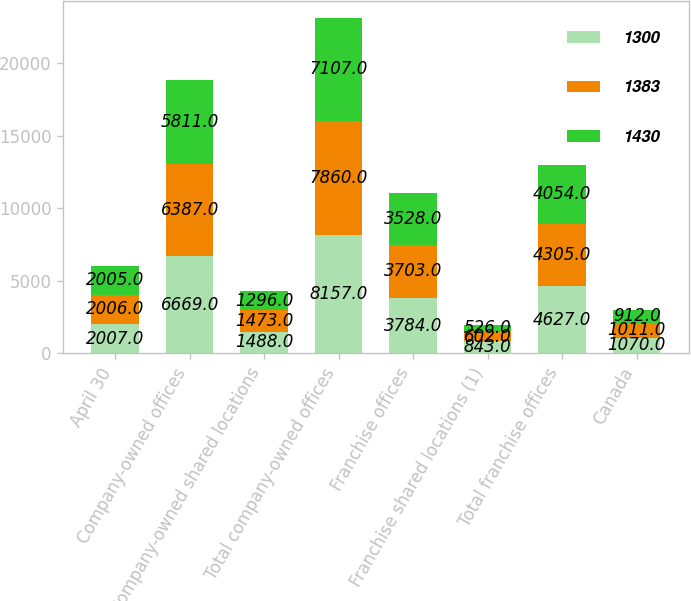Convert chart. <chart><loc_0><loc_0><loc_500><loc_500><stacked_bar_chart><ecel><fcel>April 30<fcel>Company-owned offices<fcel>Company-owned shared locations<fcel>Total company-owned offices<fcel>Franchise offices<fcel>Franchise shared locations (1)<fcel>Total franchise offices<fcel>Canada<nl><fcel>1300<fcel>2007<fcel>6669<fcel>1488<fcel>8157<fcel>3784<fcel>843<fcel>4627<fcel>1070<nl><fcel>1383<fcel>2006<fcel>6387<fcel>1473<fcel>7860<fcel>3703<fcel>602<fcel>4305<fcel>1011<nl><fcel>1430<fcel>2005<fcel>5811<fcel>1296<fcel>7107<fcel>3528<fcel>526<fcel>4054<fcel>912<nl></chart> 